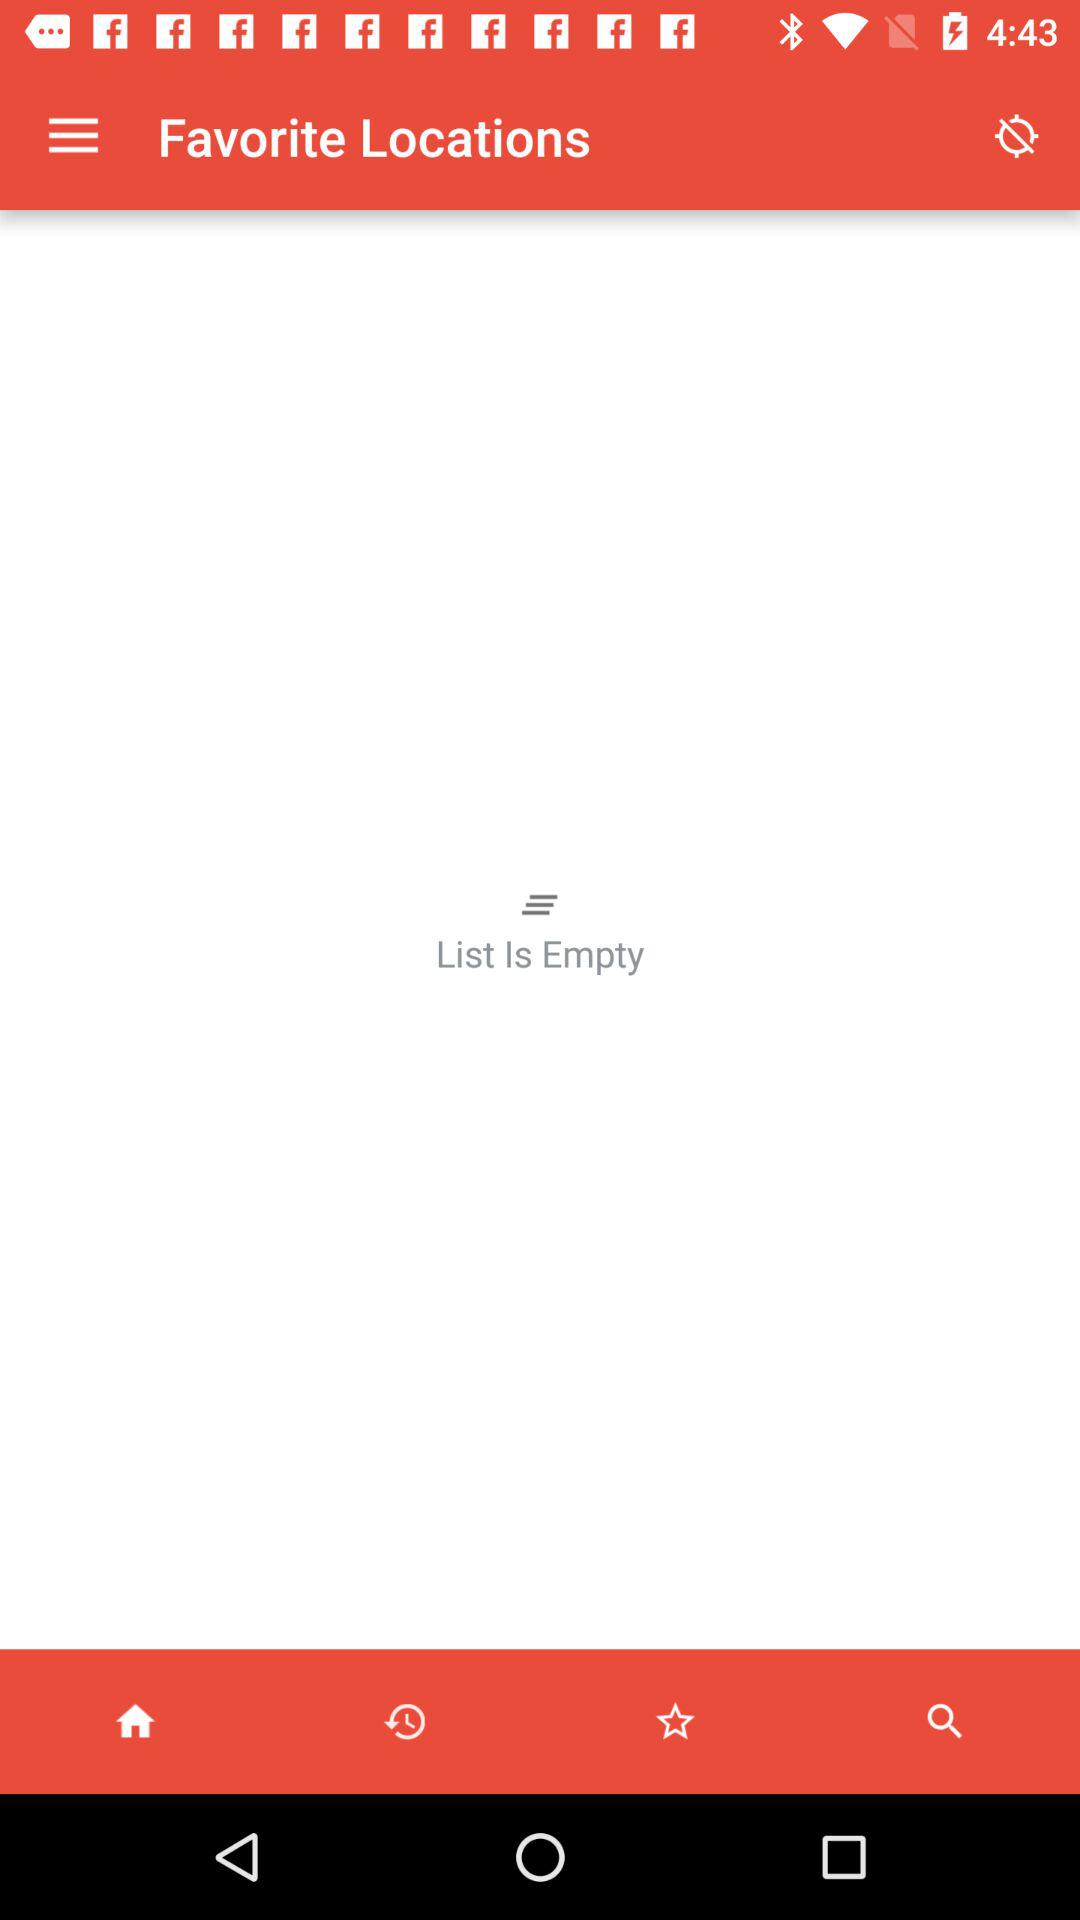What is the status of list?
When the provided information is insufficient, respond with <no answer>. <no answer> 